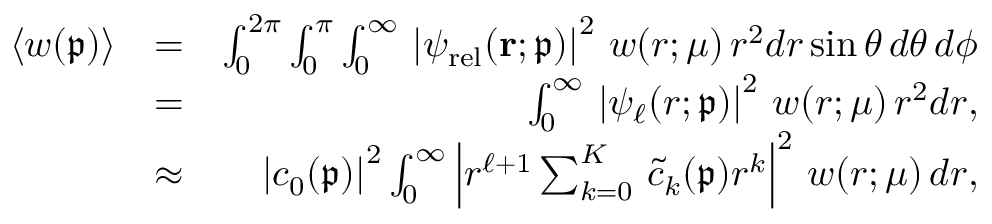Convert formula to latex. <formula><loc_0><loc_0><loc_500><loc_500>\begin{array} { r l r } { \langle \ m a t h p a l e t t e { w } ( \mathfrak { p } ) \rangle } & { = } & { \int _ { 0 } ^ { 2 \pi } \int _ { 0 } ^ { \pi } \int _ { 0 } ^ { \infty } \, \left | \psi _ { r e l } ( r ; \mathfrak { p } ) \right | ^ { 2 } \, \ m a t h p a l e t t e { w } ( r ; \mu ) \, r ^ { 2 } d r \sin \theta \, d \theta \, d \phi } \\ & { = } & { \int _ { 0 } ^ { \infty } \, \left | \psi _ { \ell } ( r ; \mathfrak { p } ) \right | ^ { 2 } \, \ m a t h p a l e t t e { w } ( r ; \mu ) \, r ^ { 2 } d r , } \\ & { \approx } & { \left | c _ { 0 } ( \mathfrak { p } ) \right | ^ { 2 } \int _ { 0 } ^ { \infty } \left | r ^ { \ell + 1 } \sum _ { k = 0 } ^ { K } \, \widetilde { c } _ { k } ( \mathfrak { p } ) r ^ { k } \right | ^ { 2 } \, \ m a t h p a l e t t e { w } ( r ; \mu ) \, d r , } \end{array}</formula> 